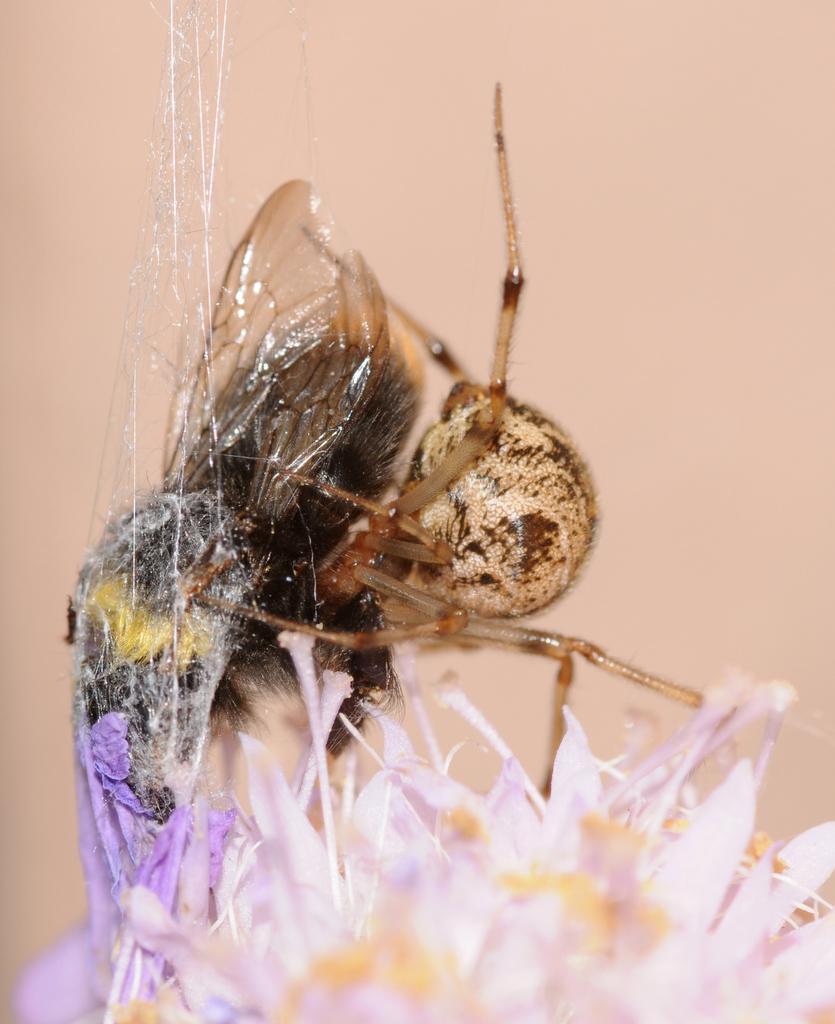Could you give a brief overview of what you see in this image? Here I can see a flower which is in violet color, on the top of it I can see a bee which is in brown color. 